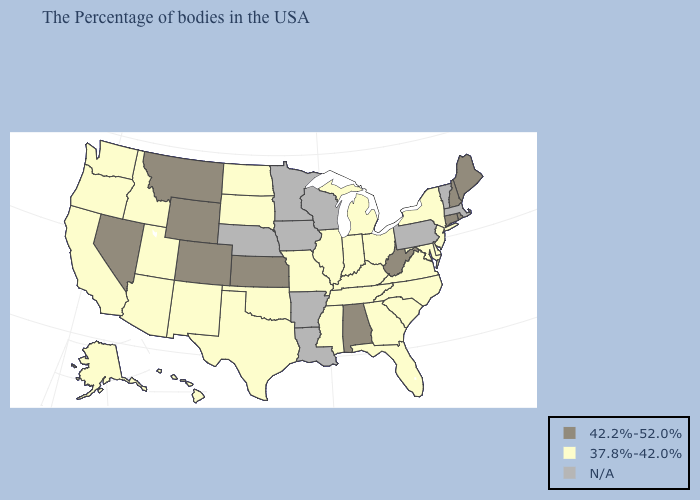Does New Jersey have the lowest value in the Northeast?
Concise answer only. Yes. Name the states that have a value in the range 37.8%-42.0%?
Quick response, please. New York, New Jersey, Delaware, Maryland, Virginia, North Carolina, South Carolina, Ohio, Florida, Georgia, Michigan, Kentucky, Indiana, Tennessee, Illinois, Mississippi, Missouri, Oklahoma, Texas, South Dakota, North Dakota, New Mexico, Utah, Arizona, Idaho, California, Washington, Oregon, Alaska, Hawaii. Name the states that have a value in the range N/A?
Short answer required. Massachusetts, Vermont, Pennsylvania, Wisconsin, Louisiana, Arkansas, Minnesota, Iowa, Nebraska. Which states have the lowest value in the USA?
Write a very short answer. New York, New Jersey, Delaware, Maryland, Virginia, North Carolina, South Carolina, Ohio, Florida, Georgia, Michigan, Kentucky, Indiana, Tennessee, Illinois, Mississippi, Missouri, Oklahoma, Texas, South Dakota, North Dakota, New Mexico, Utah, Arizona, Idaho, California, Washington, Oregon, Alaska, Hawaii. Name the states that have a value in the range 42.2%-52.0%?
Write a very short answer. Maine, Rhode Island, New Hampshire, Connecticut, West Virginia, Alabama, Kansas, Wyoming, Colorado, Montana, Nevada. Name the states that have a value in the range 42.2%-52.0%?
Write a very short answer. Maine, Rhode Island, New Hampshire, Connecticut, West Virginia, Alabama, Kansas, Wyoming, Colorado, Montana, Nevada. Does the first symbol in the legend represent the smallest category?
Keep it brief. No. Among the states that border Arizona , which have the lowest value?
Keep it brief. New Mexico, Utah, California. Which states have the highest value in the USA?
Keep it brief. Maine, Rhode Island, New Hampshire, Connecticut, West Virginia, Alabama, Kansas, Wyoming, Colorado, Montana, Nevada. Name the states that have a value in the range N/A?
Keep it brief. Massachusetts, Vermont, Pennsylvania, Wisconsin, Louisiana, Arkansas, Minnesota, Iowa, Nebraska. What is the value of Massachusetts?
Short answer required. N/A. Name the states that have a value in the range 37.8%-42.0%?
Concise answer only. New York, New Jersey, Delaware, Maryland, Virginia, North Carolina, South Carolina, Ohio, Florida, Georgia, Michigan, Kentucky, Indiana, Tennessee, Illinois, Mississippi, Missouri, Oklahoma, Texas, South Dakota, North Dakota, New Mexico, Utah, Arizona, Idaho, California, Washington, Oregon, Alaska, Hawaii. What is the lowest value in the USA?
Answer briefly. 37.8%-42.0%. What is the value of Maryland?
Write a very short answer. 37.8%-42.0%. What is the value of Kansas?
Answer briefly. 42.2%-52.0%. 